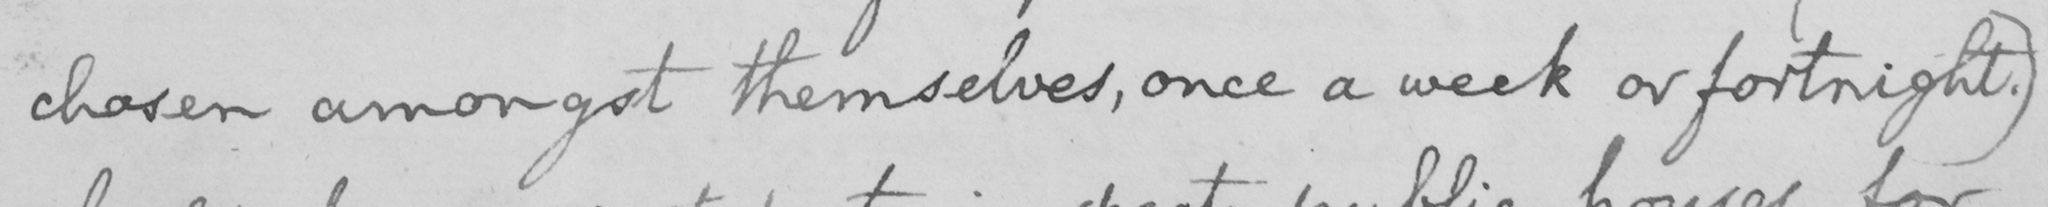What is written in this line of handwriting? chosen amongst themselves , once a week or fortnight . ) 